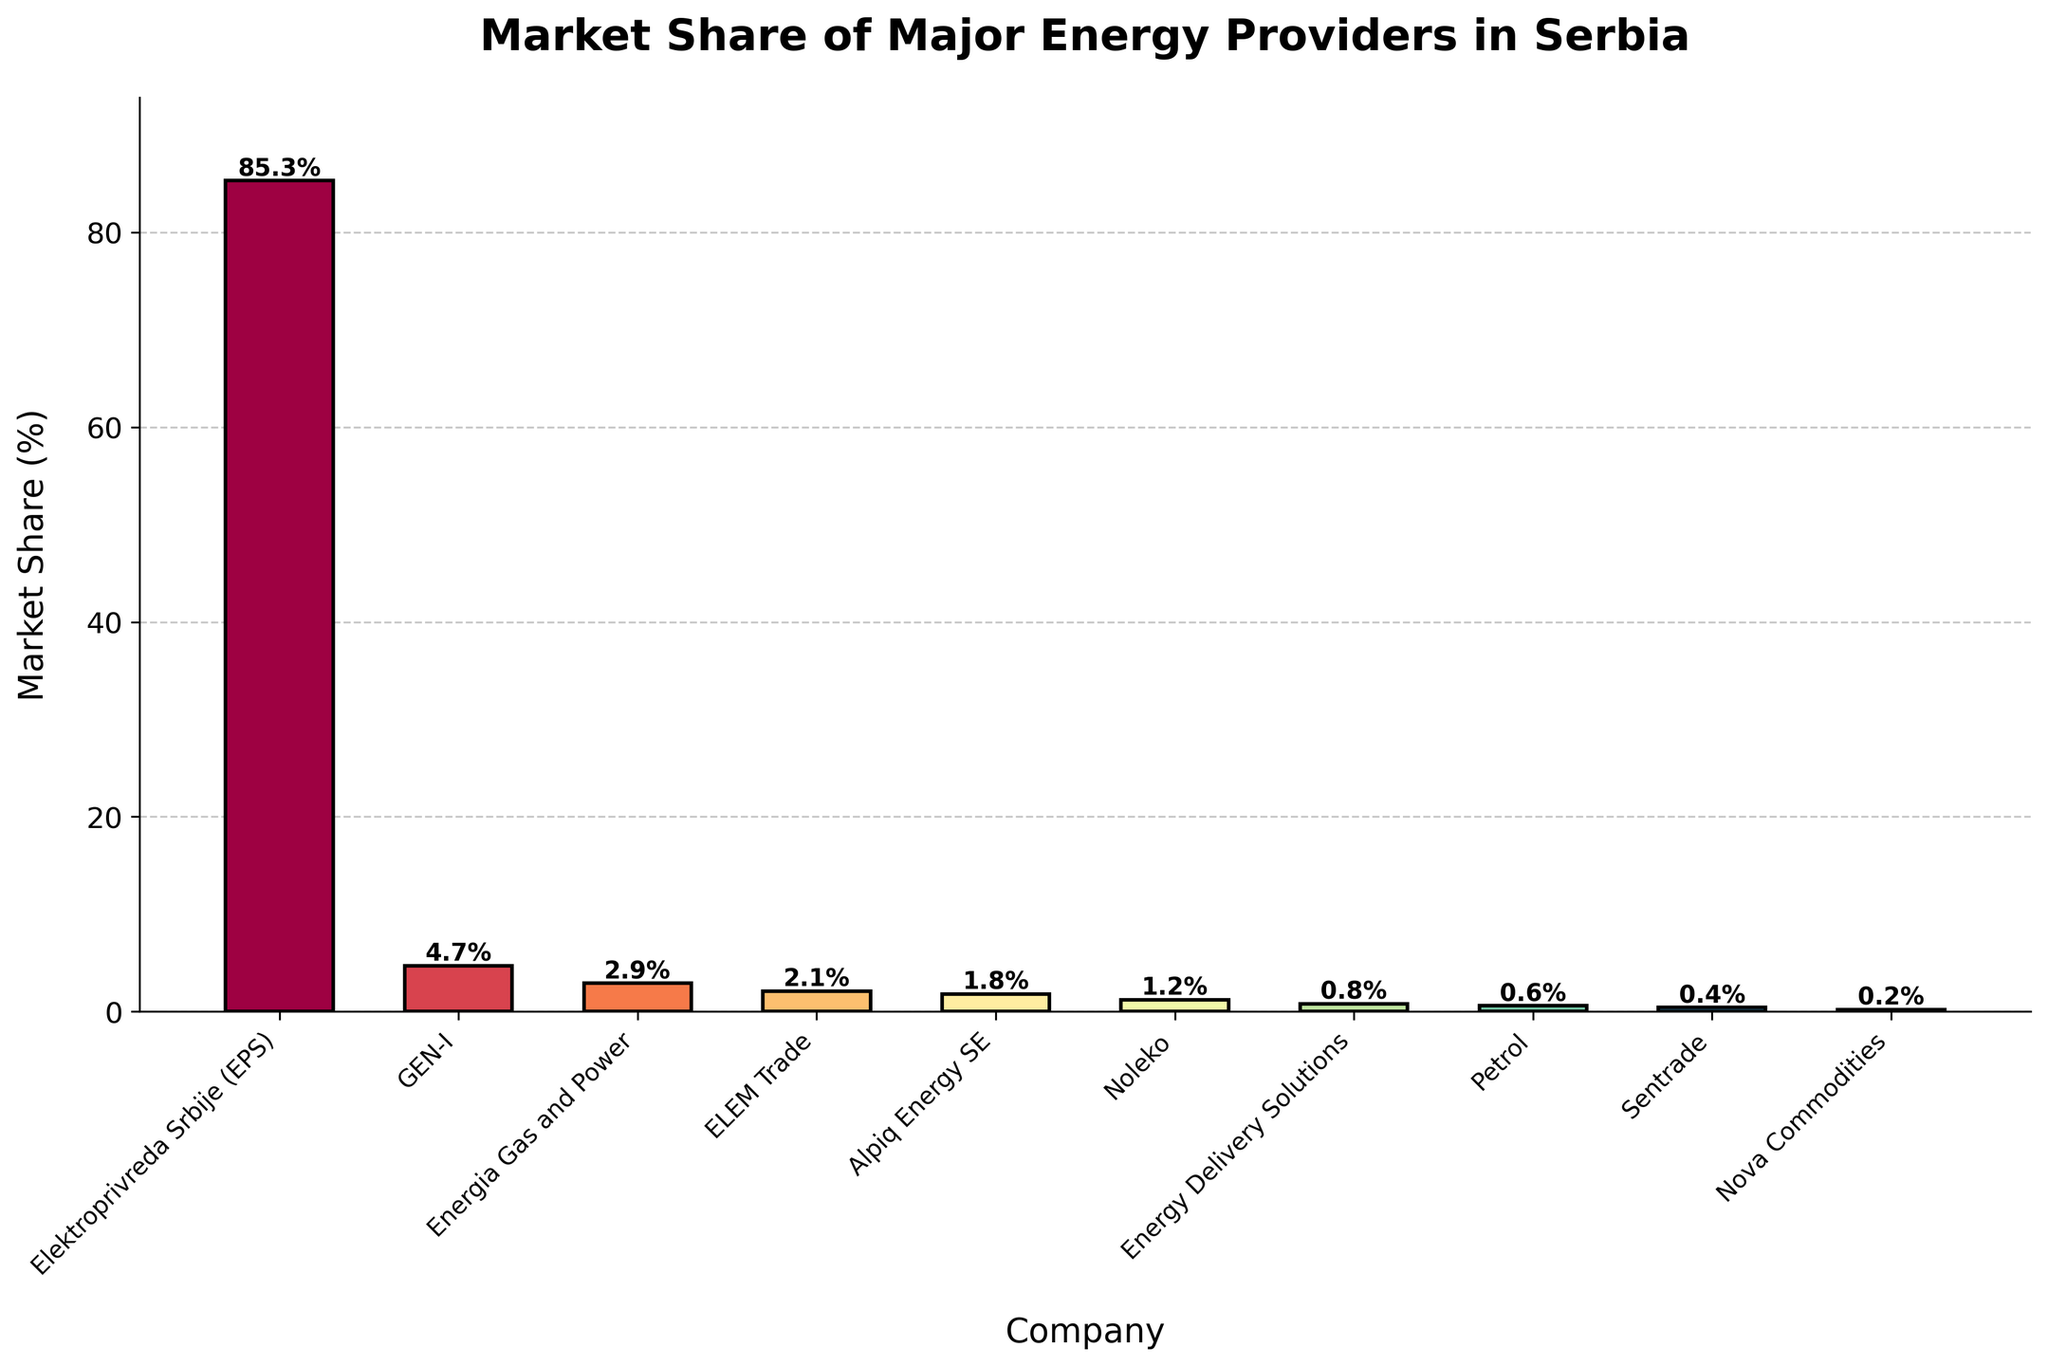What is the company with the highest market share? The figure clearly shows the bar for Elektroprivreda Srbije (EPS) as the tallest, indicating it has the highest market share.
Answer: Elektroprivreda Srbije (EPS) Which company has a smaller market share, GEN-I or Energia Gas and Power? Comparing the heights of the bars for GEN-I and Energia Gas and Power directly, the bar for Energia Gas and Power is shorter.
Answer: Energia Gas and Power What is the total market share of companies with less than 1% market share each? The companies with less than 1% market share are Energy Delivery Solutions (0.8%), Petrol (0.6%), Sentrade (0.4%), and Nova Commodities (0.2%). Summing these shares: 0.8 + 0.6 + 0.4 + 0.2 = 2%.
Answer: 2% Which three companies have the smallest market shares? The figure shows the shortest bars correspond to Nova Commodities, Sentrade, and Petrol.
Answer: Nova Commodities, Sentrade, Petrol What's the difference in market share between the company with the second-highest market share and the company with the third-highest market share? The second-highest market share is GEN-I with 4.7%, and the third-highest is Energia Gas and Power with 2.9%. The difference is 4.7% - 2.9% = 1.8%.
Answer: 1.8% Which bar is colored the most distinctly from the others? The color scheme in the plot uses a gradient of the Spectral colormap, leading to the most distinctly colored bar being the first or last in the sequence. The first bar (EPS) is prominently distinct due to its color and height.
Answer: Elektroprivreda Srbije (EPS) What is the combined market share of ELEM Trade and Alpiq Energy SE? The market share of ELEM Trade is 2.1% and Alpiq Energy SE is 1.8%. Summing these: 2.1% + 1.8% = 3.9%.
Answer: 3.9% Are there more companies with a market share above or below 1%? Companies with a market share above 1% are EPS, GEN-I, Energia Gas and Power, ELEM Trade, Alpiq Energy SE, and Noleko (6 companies). Companies with a market share below 1% are Energy Delivery Solutions, Petrol, Sentrade, and Nova Commodities (4 companies).
Answer: Above 1% Which company approximately occupies a quarter of the total market occupied by Elektroprivreda Srbije (EPS)? EPS has a market share of 85.3%. A quarter of 85.3% is approximately 85.3 / 4 = 21.325%. None of the companies have this exact share but the other companies combined have a smaller share.
Answer: None of the companies 